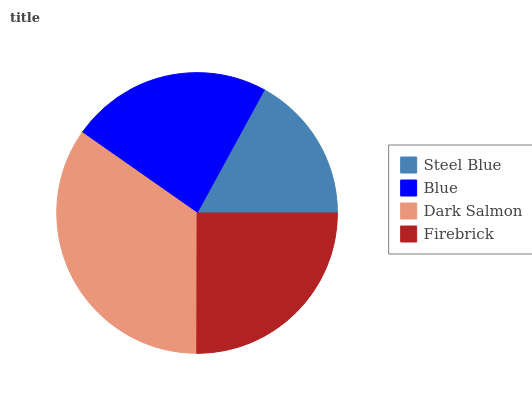Is Steel Blue the minimum?
Answer yes or no. Yes. Is Dark Salmon the maximum?
Answer yes or no. Yes. Is Blue the minimum?
Answer yes or no. No. Is Blue the maximum?
Answer yes or no. No. Is Blue greater than Steel Blue?
Answer yes or no. Yes. Is Steel Blue less than Blue?
Answer yes or no. Yes. Is Steel Blue greater than Blue?
Answer yes or no. No. Is Blue less than Steel Blue?
Answer yes or no. No. Is Firebrick the high median?
Answer yes or no. Yes. Is Blue the low median?
Answer yes or no. Yes. Is Steel Blue the high median?
Answer yes or no. No. Is Firebrick the low median?
Answer yes or no. No. 